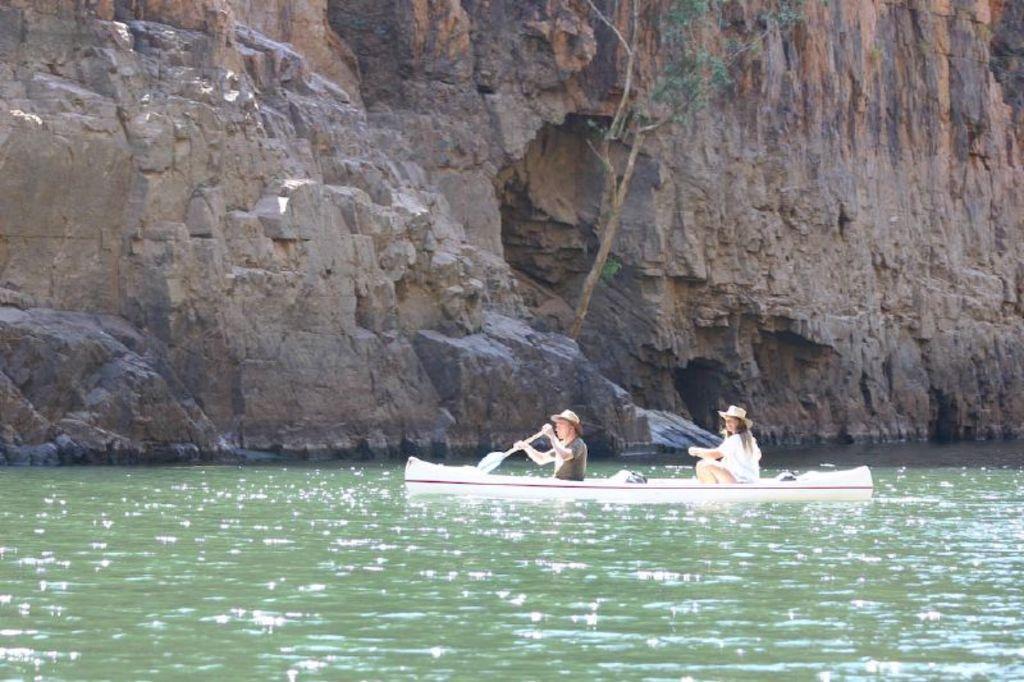Describe this image in one or two sentences. In this image I can see the rock and two people are sitting in the boat and holding paddles. The boat is on the water surface. 